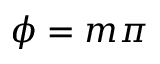Convert formula to latex. <formula><loc_0><loc_0><loc_500><loc_500>\phi = m \pi</formula> 